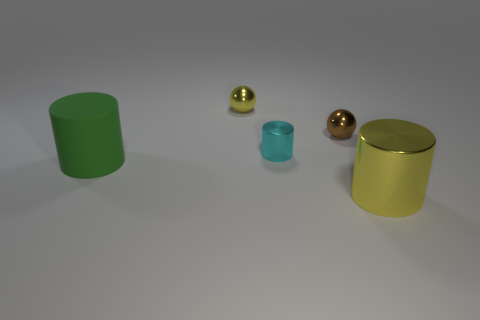Add 3 tiny yellow spheres. How many objects exist? 8 Subtract all small metal cylinders. How many cylinders are left? 2 Subtract all yellow cylinders. How many cylinders are left? 2 Subtract all cyan balls. How many yellow cylinders are left? 1 Subtract all matte things. Subtract all large purple shiny balls. How many objects are left? 4 Add 3 tiny brown objects. How many tiny brown objects are left? 4 Add 4 tiny blue cubes. How many tiny blue cubes exist? 4 Subtract 0 blue cylinders. How many objects are left? 5 Subtract all balls. How many objects are left? 3 Subtract 3 cylinders. How many cylinders are left? 0 